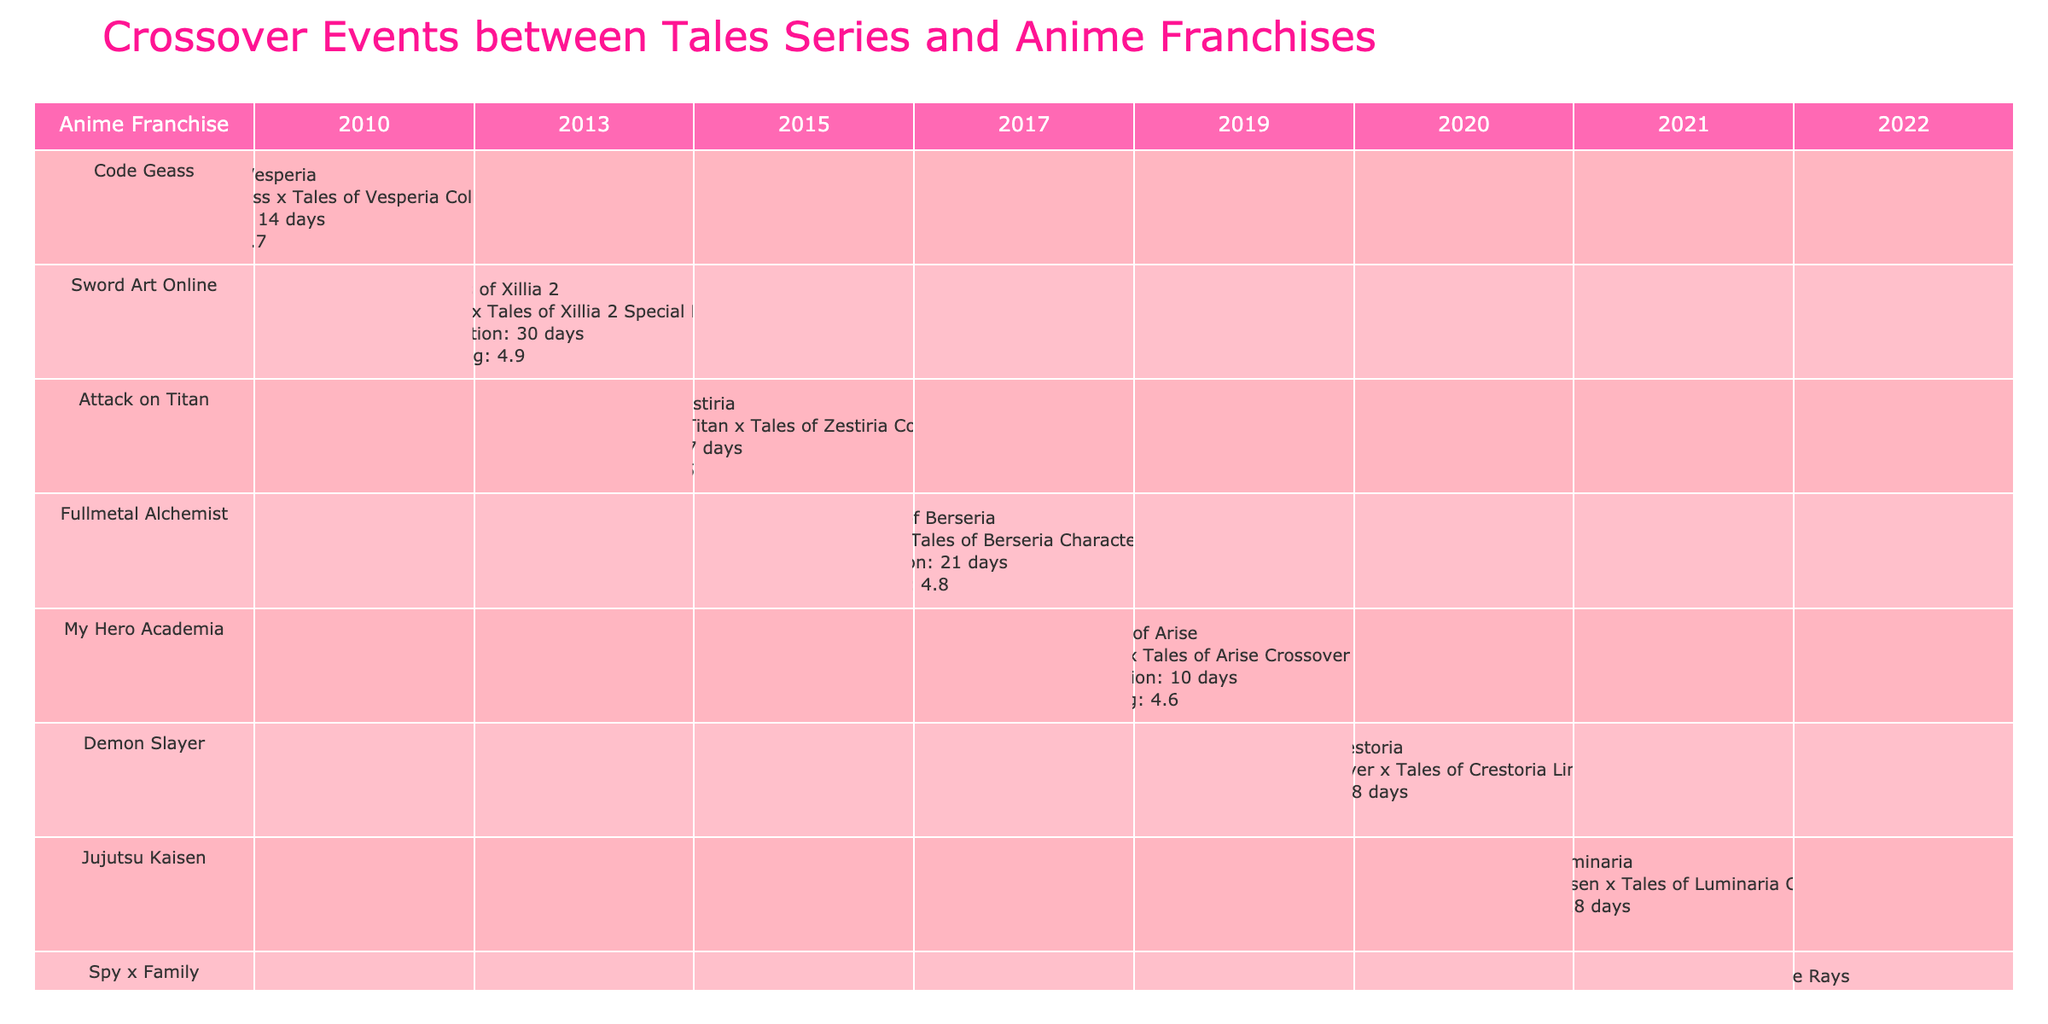What was the fan rating for the crossover event between Attack on Titan and Tales of Zestiria? The table shows the crossover event "Attack on Titan x Tales of Zestiria Costume DLC" has a fan rating of 4.5.
Answer: 4.5 Which crossover event lasted the longest? The table lists the longest duration event, "SAO x Tales of Xillia 2 Special Event," which lasted for 30 days.
Answer: 30 days Did any crossover event in 2021 feature a duration of less than 20 days? The event "Jujutsu Kaisen x Tales of Luminaria Collab Event" in 2021 had a duration of 18 days, which is less than 20 days.
Answer: Yes What is the average fan rating of crossover events from 2010 to 2020? The ratings from the events from 2010 to 2020 are 4.7, 4.9, 4.5, 4.8, 4.6, and 4.9. Summing these gives 29.4, and there are 6 events, so the average rating is 29.4 / 6 = 4.9.
Answer: 4.9 Which anime franchise had a crossover event with the highest fan rating, and what was the rating? The table shows that both crossover events in 2013 with "Sword Art Online" and in 2020 with "Demon Slayer" had the highest fan rating of 4.9.
Answer: Sword Art Online and Demon Slayer; 4.9 How many days did the crossover event between My Hero Academia and Tales of Arise last? The table states that the event "MHA x Tales of Arise Crossover Quest" lasted for 10 days.
Answer: 10 days Was there a crossover event between the Tales series and Fullmetal Alchemist after 2017? The only event listed involving Fullmetal Alchemist is from 2017, so there are no events after that year.
Answer: No What is the total duration of all crossover events listed in 2019 and 2020? The durations for events in 2019 and 2020 are 10 days (2019) and 28 days (2020). Adding these gives a total duration of 10 + 28 = 38 days.
Answer: 38 days Which anime franchise appeared in collaboration with Tales of Xillia 2? According to the table, the franchise that collaborated with Tales of Xillia 2 is Sword Art Online.
Answer: Sword Art Online Did any crossover event feature a character swap? Yes, the table indicates that "FMA x Tales of Berseria Character Swap" was a crossover event involving character swapping.
Answer: Yes 